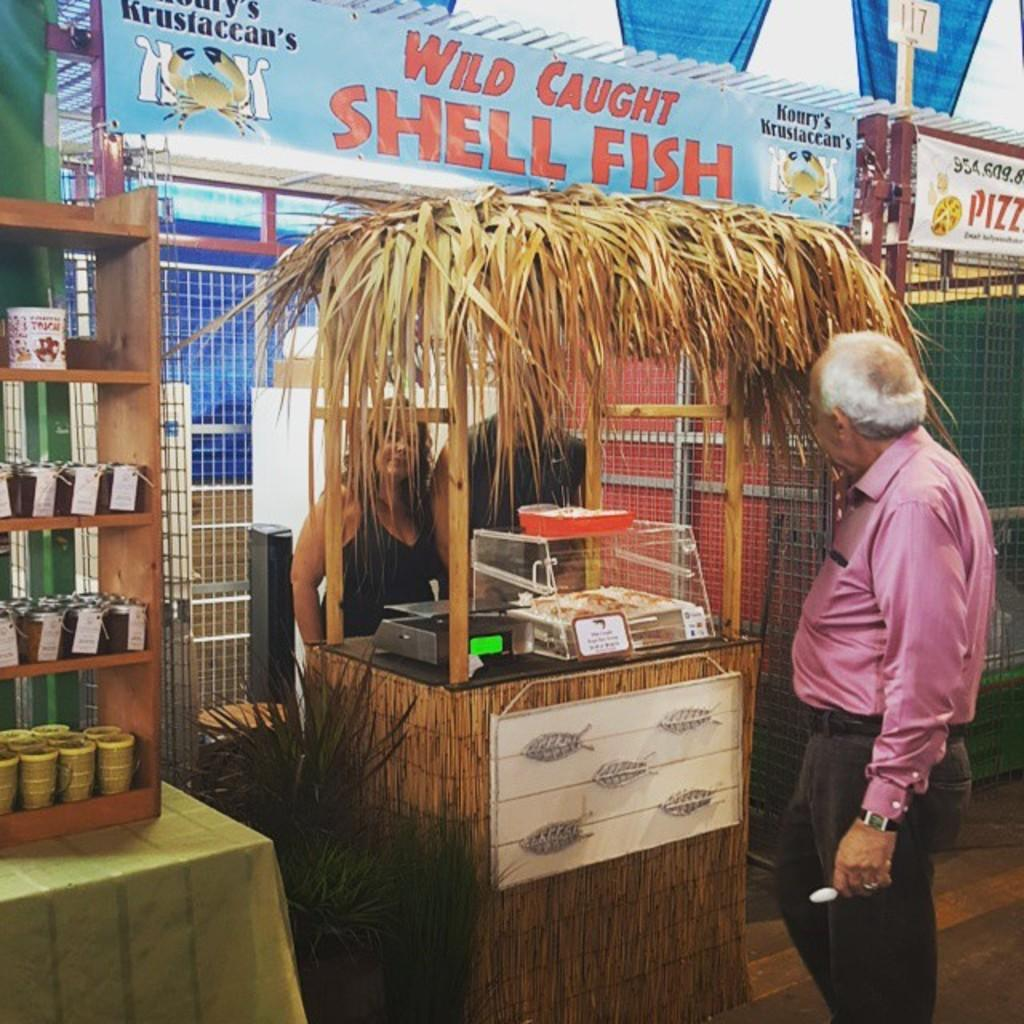Provide a one-sentence caption for the provided image. A man looking at a wild caught shell fish stand. 